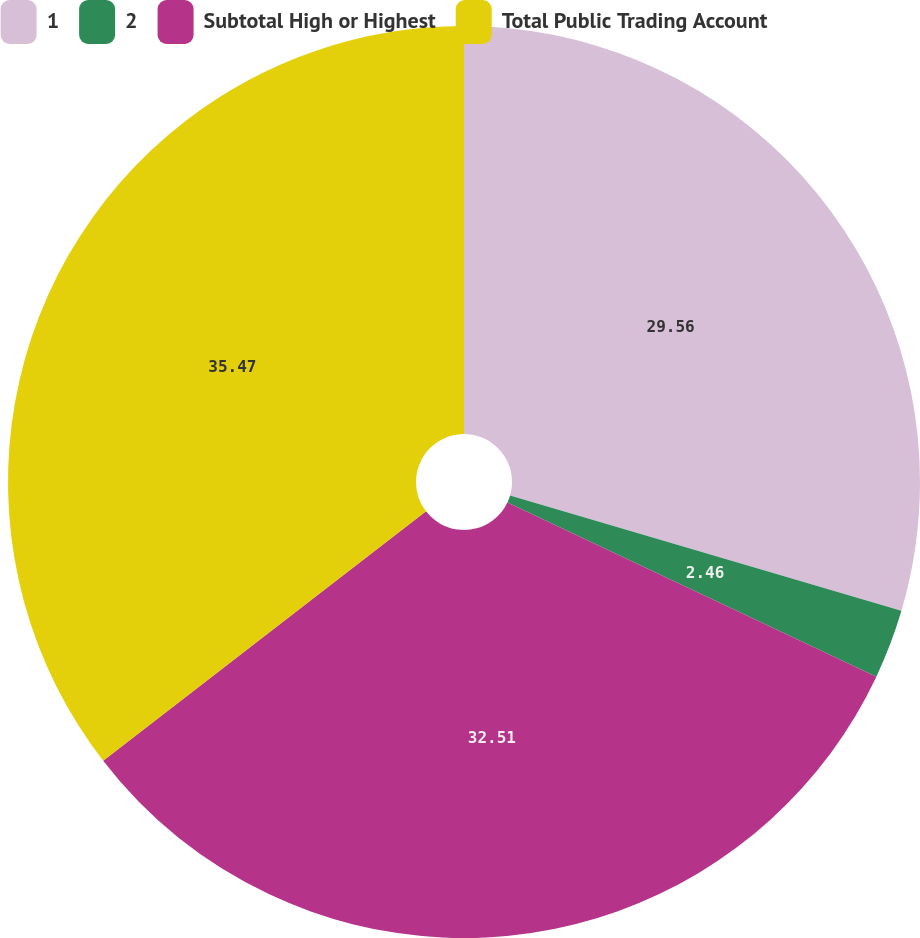Convert chart to OTSL. <chart><loc_0><loc_0><loc_500><loc_500><pie_chart><fcel>1<fcel>2<fcel>Subtotal High or Highest<fcel>Total Public Trading Account<nl><fcel>29.56%<fcel>2.46%<fcel>32.51%<fcel>35.47%<nl></chart> 